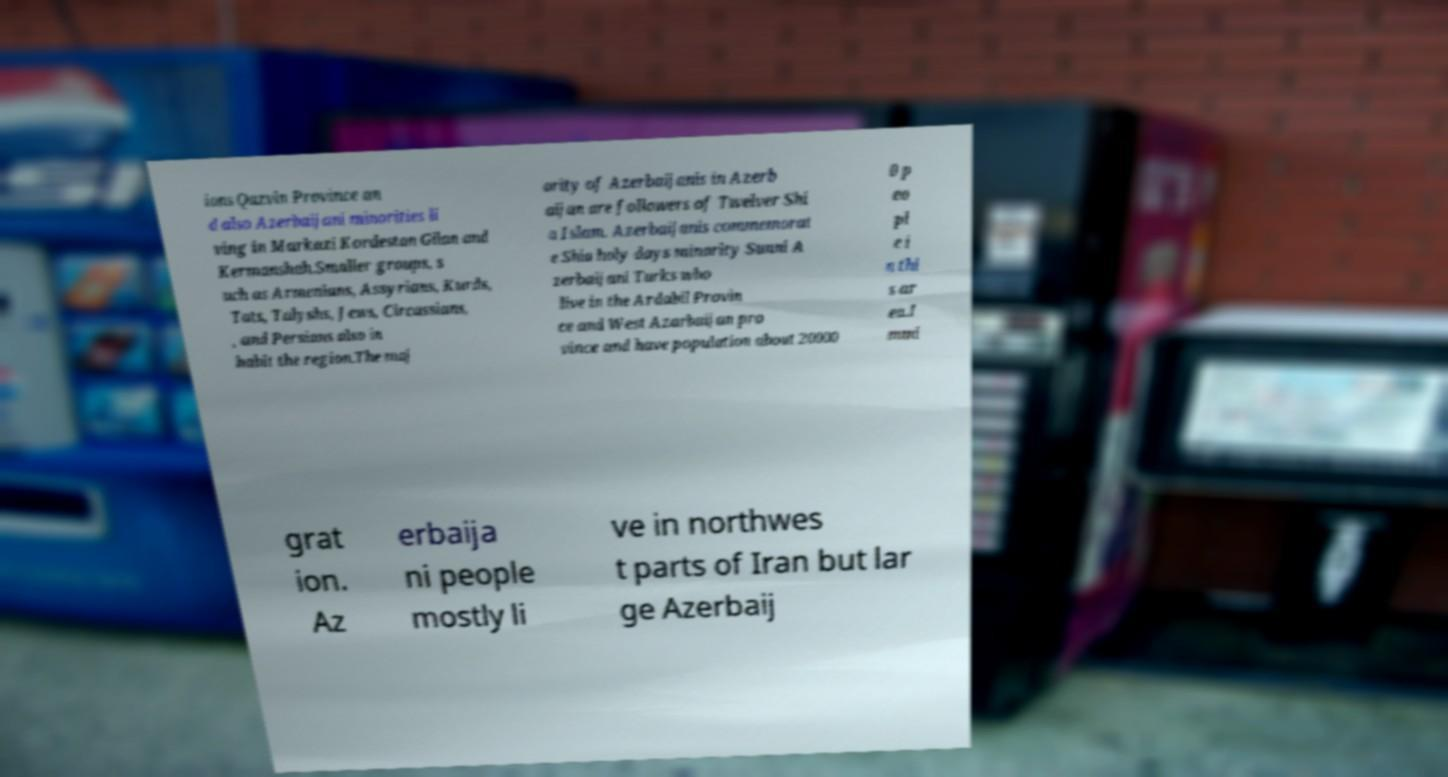Could you assist in decoding the text presented in this image and type it out clearly? ions Qazvin Province an d also Azerbaijani minorities li ving in Markazi Kordestan Gilan and Kermanshah.Smaller groups, s uch as Armenians, Assyrians, Kurds, Tats, Talyshs, Jews, Circassians, , and Persians also in habit the region.The maj ority of Azerbaijanis in Azerb aijan are followers of Twelver Shi a Islam. Azerbaijanis commemorat e Shia holy days minority Sunni A zerbaijani Turks who live in the Ardabil Provin ce and West Azarbaijan pro vince and have population about 20000 0 p eo pl e i n thi s ar ea.I mmi grat ion. Az erbaija ni people mostly li ve in northwes t parts of Iran but lar ge Azerbaij 